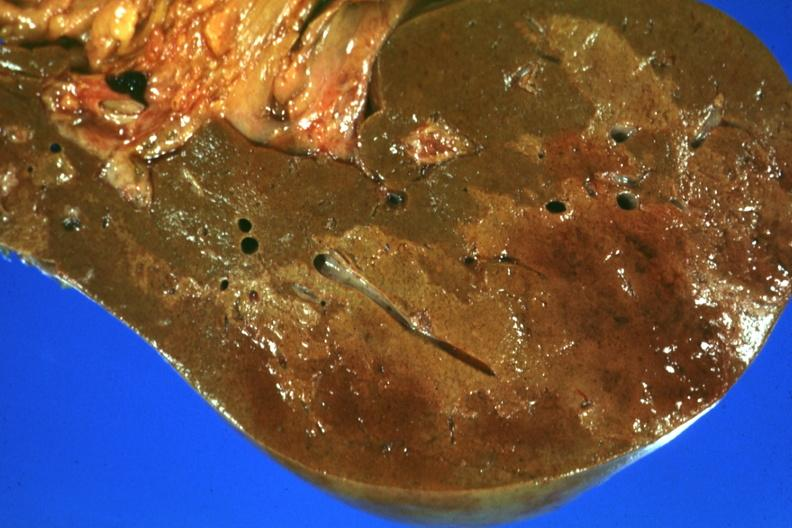how does this image show frontal section?
Answer the question using a single word or phrase. With large patch of central infarction well seen 